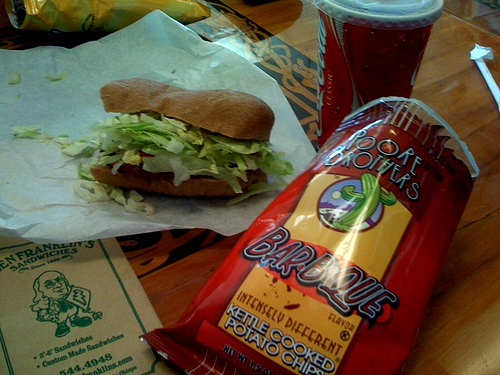How many cups? There is 1 cup visible in the image, located to the right of the sandwich and slightly obscured by the bag of barbecue-flavored potato chips. 